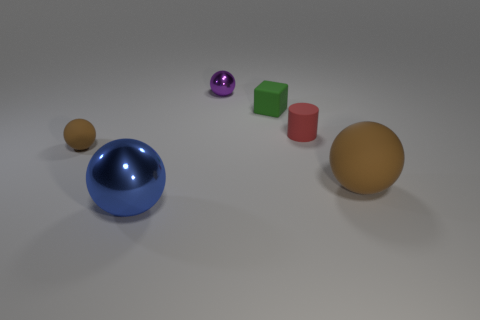Can you tell me about the objects grouped together in the center? Certainly! In the center, there is a small purple sphere, flanked by two cubes—one green and one red. They are positioned in a straight line and exhibit a smooth, matte finish except for the reflective surface of the sphere. 